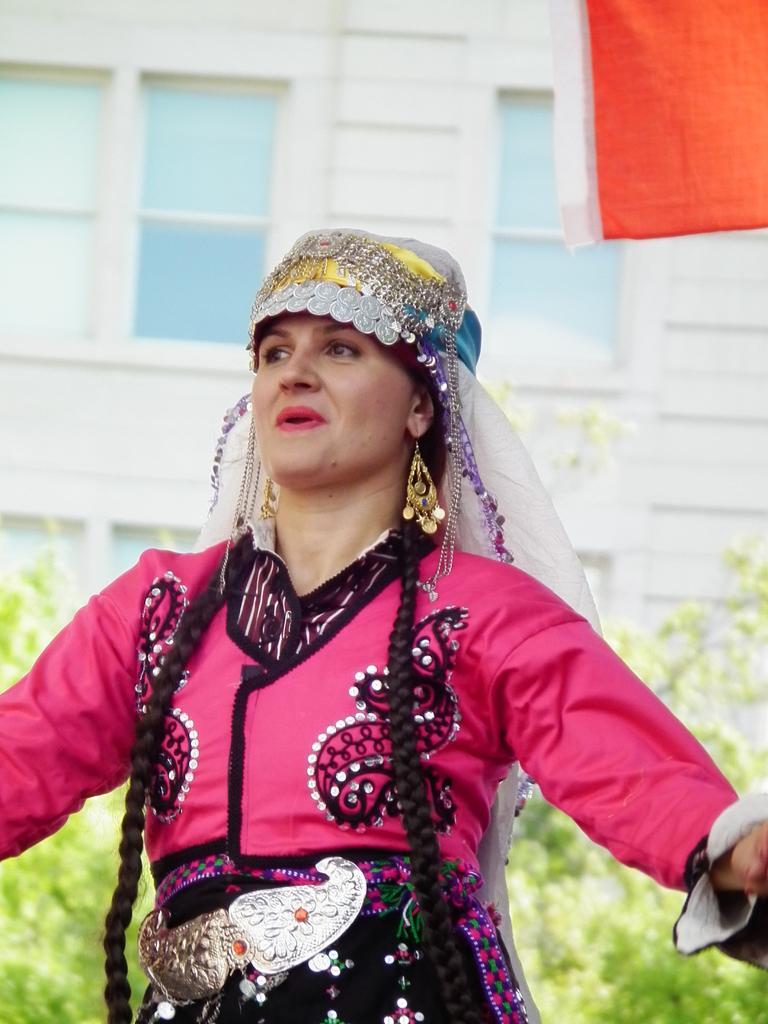Could you give a brief overview of what you see in this image? This is the picture of a person in pink dress, golden earrings,behind there are some plants, building which has windows. 